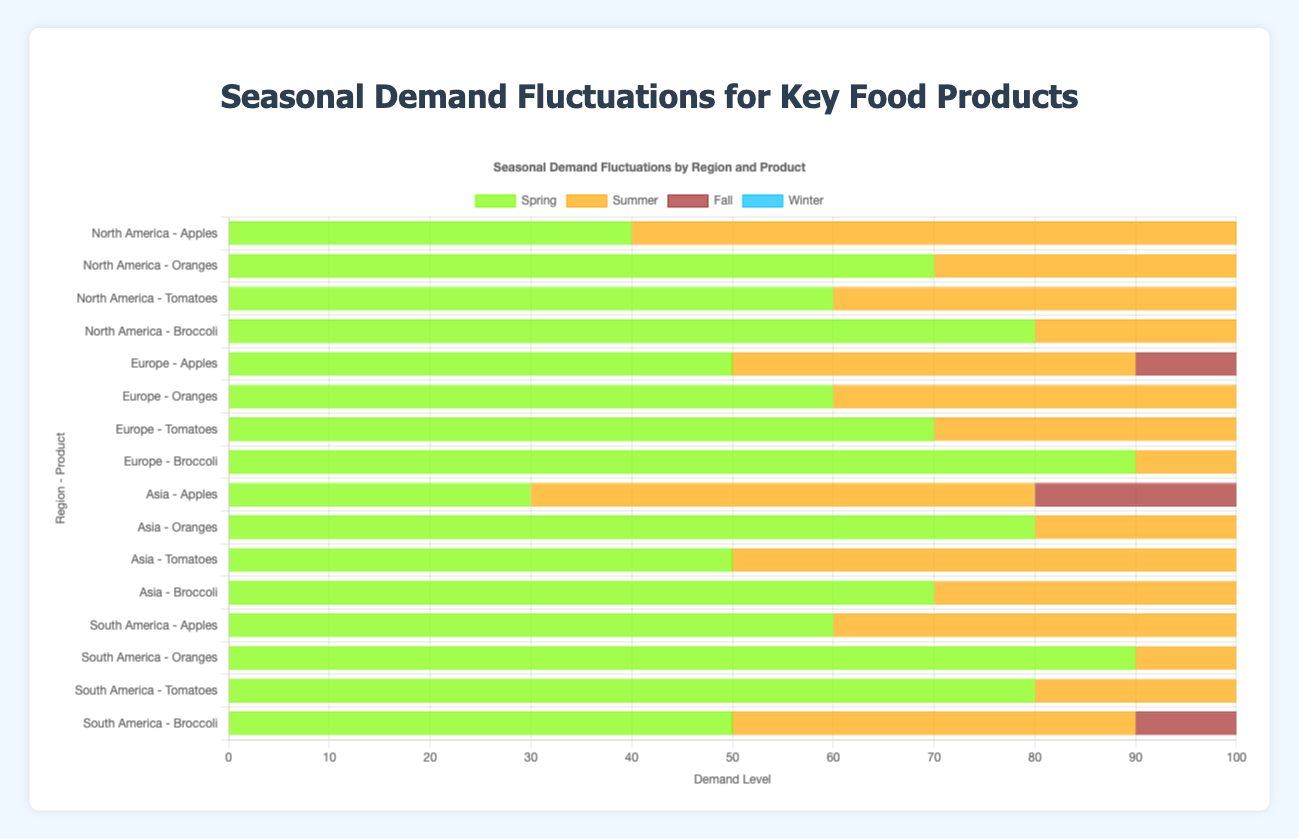Which region has the highest demand for apples in the Fall? In the chart, look for demand levels of apples in the Fall season across all regions. The highest value for apples in the Fall is for Europe with a demand of 90.
Answer: Europe What is the average demand for oranges in Winter across all regions? To calculate the average, add the Winter demand for oranges in each region first: 80 (NA) + 90 (EU) + 70 (AS) + 80 (SA) = 320. Then, divide by the number of regions (4): 320/4 = 80.
Answer: 80 Which product has the most consistent demand across all seasons in Asia? By comparing the demand values for each product (Apples, Oranges, Tomatoes, and Broccoli) across all seasons in Asia, Broccoli has the most consistent values (Spring: 70, Summer: 50, Fall: 60, Winter: 40).
Answer: Broccoli In which season does North America see the lowest combined demand for all products? Sum the demands for all products in each season for North America then compare: Spring (40 + 70 + 60 + 80 = 250), Summer (60 + 50 + 90 + 50 = 250), Fall (80 + 30 + 70 + 60 = 240), Winter (30 + 80 + 20 + 40 = 170). Winter has the lowest combined demand (170).
Answer: Winter Does Europe or South America have a higher overall winter demand for all products combined? Calculate the sum of Winter demands for each product in both Europe and South America. Europe: 20 (Apples) + 90 (Oranges) + 30 (Tomatoes) + 30 (Broccoli) = 170. South America: 30 (Apples) + 80 (Oranges) + 40 (Tomatoes) + 60 (Broccoli) = 210.
Answer: South America Which product in North America has the highest demand in Summer? Examine the summer demand levels for all products in North America: Apples (60), Oranges (50), Tomatoes (90), and Broccoli (50). Tomatoes have the highest demand with 90.
Answer: Tomatoes What is the difference in demand for broccoli between Spring and Winter in South America? Find the demand for broccoli in both Spring and Winter in South America: Spring (50), Winter (60). The difference is: 60 - 50 = 10.
Answer: 10 Compare the summer demand for tomatoes between Asia and Europe. Which one is higher? Look at the summer demand for tomatoes in both regions: Asia (90), Europe (80). Asia has a higher summer demand for tomatoes.
Answer: Asia Which product in Europe has the highest demand in Spring? Check the Spring demand levels for all products in Europe: Apples (50), Oranges (60), Tomatoes (70), Broccoli (90). Broccoli has the highest demand with 90.
Answer: Broccoli What is the total demand for all products in Spring in South America? Sum the Spring demand for all products in South America: Apples (60), Oranges (90), Tomatoes (80), Broccoli (50). Total: 60 + 90 + 80 + 50 = 280.
Answer: 280 